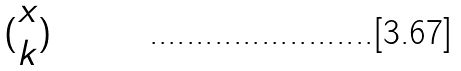<formula> <loc_0><loc_0><loc_500><loc_500>( \begin{matrix} x \\ k \end{matrix} )</formula> 